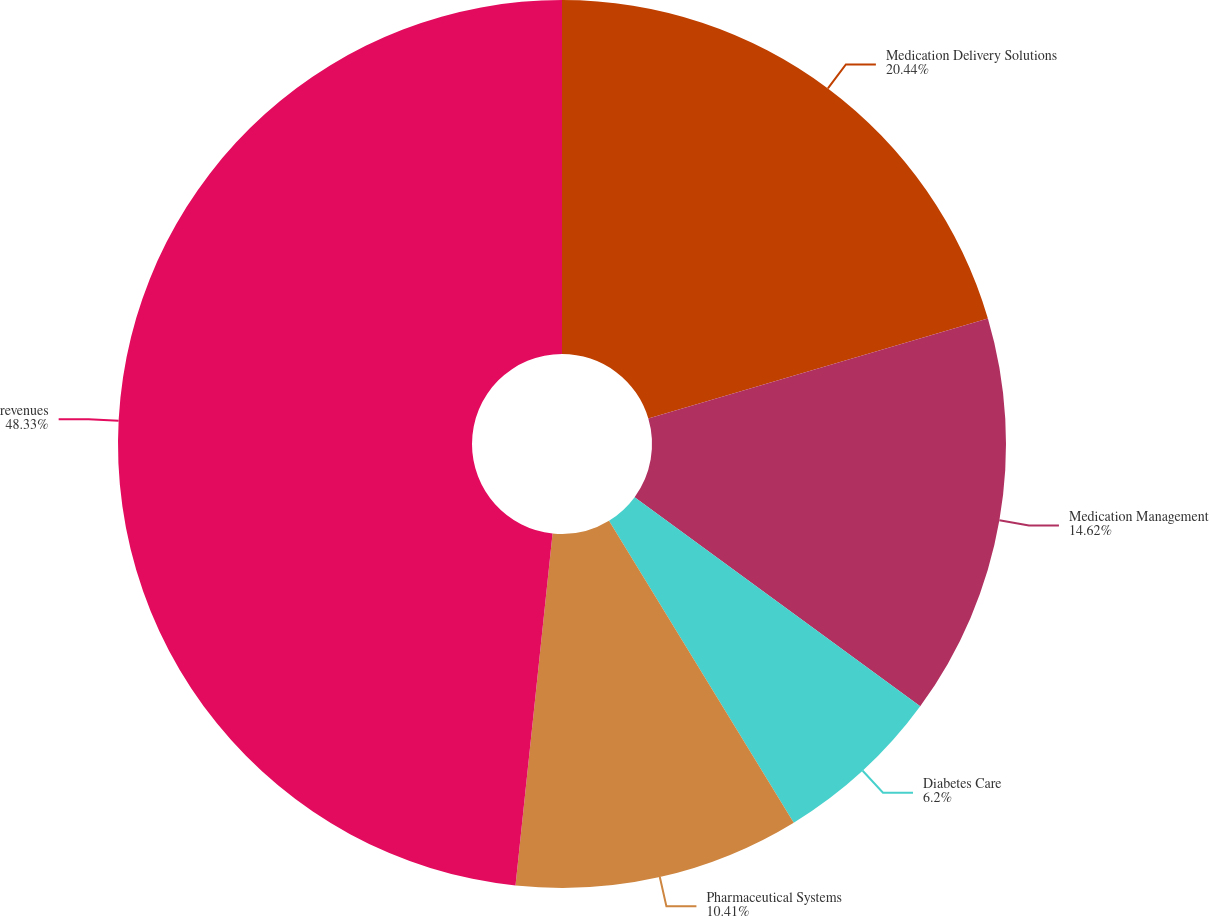Convert chart to OTSL. <chart><loc_0><loc_0><loc_500><loc_500><pie_chart><fcel>Medication Delivery Solutions<fcel>Medication Management<fcel>Diabetes Care<fcel>Pharmaceutical Systems<fcel>revenues<nl><fcel>20.44%<fcel>14.62%<fcel>6.2%<fcel>10.41%<fcel>48.33%<nl></chart> 